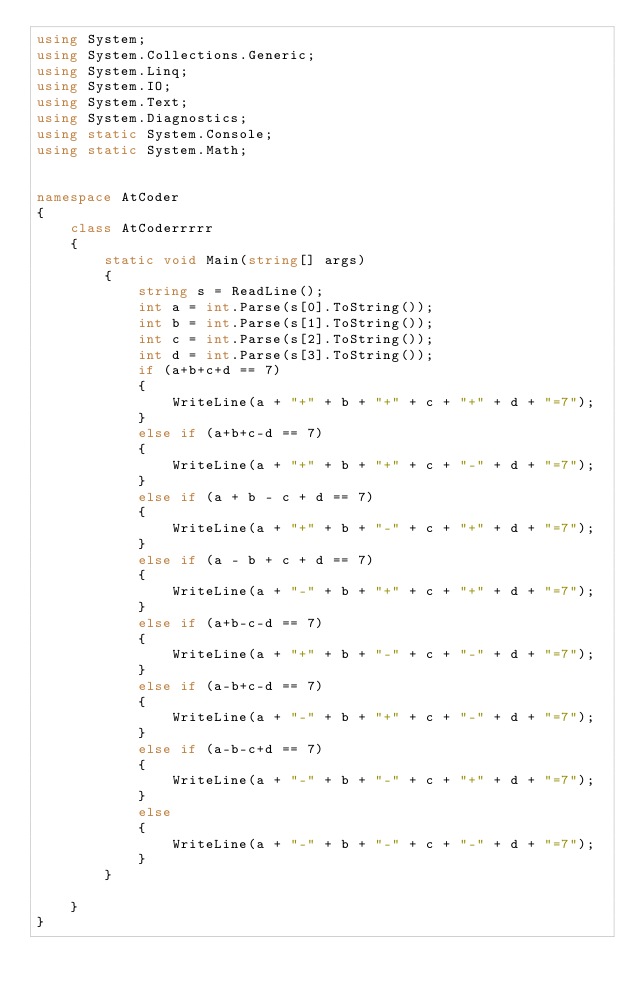<code> <loc_0><loc_0><loc_500><loc_500><_C#_>using System;
using System.Collections.Generic;
using System.Linq;
using System.IO;
using System.Text;
using System.Diagnostics;
using static System.Console;
using static System.Math;


namespace AtCoder
{
    class AtCoderrrrr
    {
        static void Main(string[] args)
        {
            string s = ReadLine();
            int a = int.Parse(s[0].ToString());
            int b = int.Parse(s[1].ToString());
            int c = int.Parse(s[2].ToString());
            int d = int.Parse(s[3].ToString());
            if (a+b+c+d == 7)
            {
                WriteLine(a + "+" + b + "+" + c + "+" + d + "=7");
            }
            else if (a+b+c-d == 7)
            {
                WriteLine(a + "+" + b + "+" + c + "-" + d + "=7");
            }
            else if (a + b - c + d == 7)
            {
                WriteLine(a + "+" + b + "-" + c + "+" + d + "=7");
            }
            else if (a - b + c + d == 7)
            {
                WriteLine(a + "-" + b + "+" + c + "+" + d + "=7");
            }
            else if (a+b-c-d == 7)
            {
                WriteLine(a + "+" + b + "-" + c + "-" + d + "=7");
            }
            else if (a-b+c-d == 7)
            {
                WriteLine(a + "-" + b + "+" + c + "-" + d + "=7");
            }
            else if (a-b-c+d == 7)
            {
                WriteLine(a + "-" + b + "-" + c + "+" + d + "=7");
            }
            else
            {
                WriteLine(a + "-" + b + "-" + c + "-" + d + "=7");
            }
        }
        
    }
}
</code> 